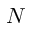<formula> <loc_0><loc_0><loc_500><loc_500>N</formula> 